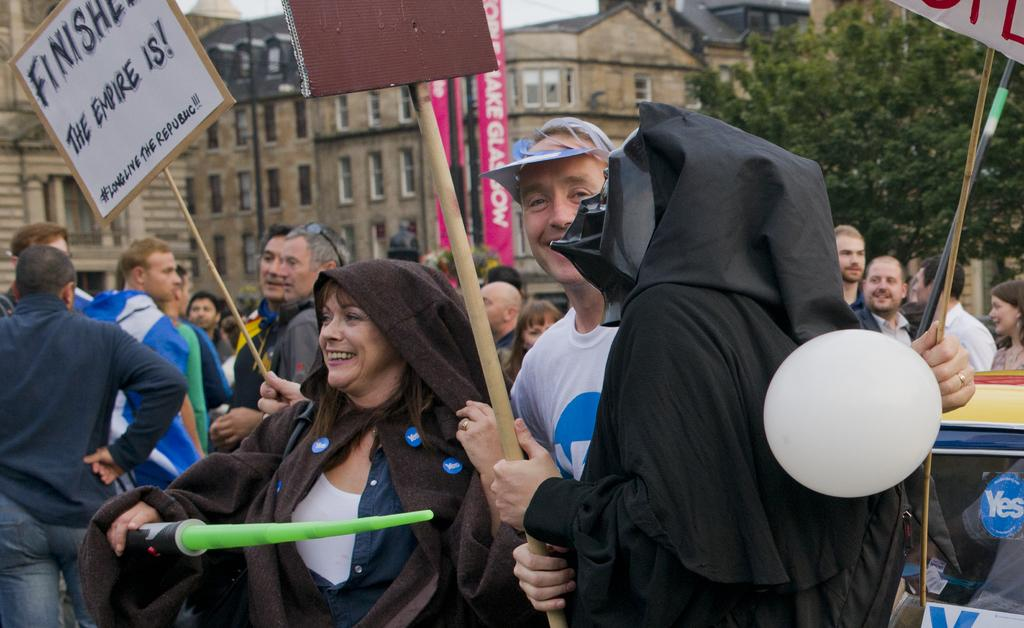What are the people in the image doing? The people in the image are standing and holding banners and posters. What might the banners and posters represent? The banners and posters might represent a cause or message that the people are supporting or promoting. What can be seen in the background of the image? There are trees and buildings in the background of the image. What type of boat is visible in the image? There is no boat present in the image. What kind of breakfast is being served in the image? There is no breakfast present in the image. 